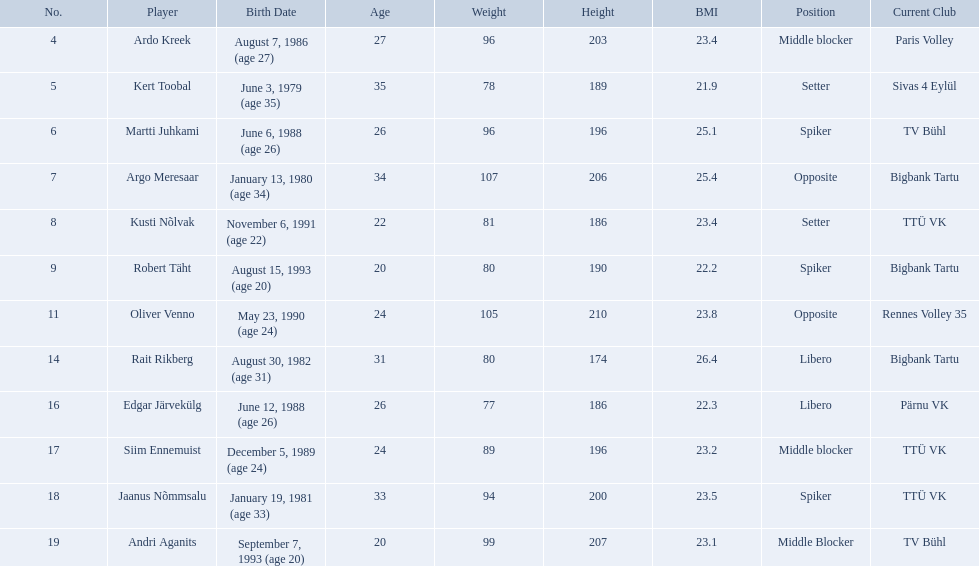Who are all of the players? Ardo Kreek, Kert Toobal, Martti Juhkami, Argo Meresaar, Kusti Nõlvak, Robert Täht, Oliver Venno, Rait Rikberg, Edgar Järvekülg, Siim Ennemuist, Jaanus Nõmmsalu, Andri Aganits. How tall are they? 203, 189, 196, 206, 186, 190, 210, 174, 186, 196, 200, 207. And which player is tallest? Oliver Venno. Who are the players of the estonian men's national volleyball team? Ardo Kreek, Kert Toobal, Martti Juhkami, Argo Meresaar, Kusti Nõlvak, Robert Täht, Oliver Venno, Rait Rikberg, Edgar Järvekülg, Siim Ennemuist, Jaanus Nõmmsalu, Andri Aganits. Of these, which have a height over 200? Ardo Kreek, Argo Meresaar, Oliver Venno, Andri Aganits. Of the remaining, who is the tallest? Oliver Venno. What are the heights in cm of the men on the team? 203, 189, 196, 206, 186, 190, 210, 174, 186, 196, 200, 207. What is the tallest height of a team member? 210. Which player stands at 210? Oliver Venno. 